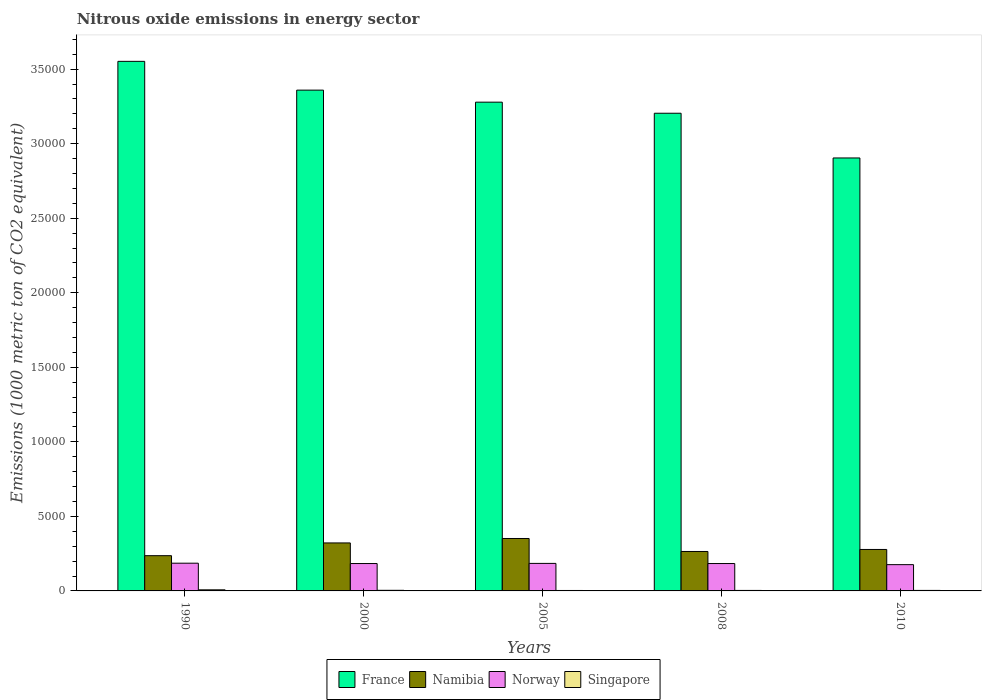How many different coloured bars are there?
Your answer should be very brief. 4. How many groups of bars are there?
Provide a succinct answer. 5. Are the number of bars on each tick of the X-axis equal?
Your response must be concise. Yes. How many bars are there on the 2nd tick from the left?
Your answer should be very brief. 4. How many bars are there on the 4th tick from the right?
Your answer should be very brief. 4. What is the label of the 3rd group of bars from the left?
Your response must be concise. 2005. What is the amount of nitrous oxide emitted in France in 2000?
Give a very brief answer. 3.36e+04. Across all years, what is the maximum amount of nitrous oxide emitted in Singapore?
Give a very brief answer. 73.5. Across all years, what is the minimum amount of nitrous oxide emitted in Norway?
Offer a terse response. 1762.1. In which year was the amount of nitrous oxide emitted in France maximum?
Provide a succinct answer. 1990. In which year was the amount of nitrous oxide emitted in Singapore minimum?
Ensure brevity in your answer.  2005. What is the total amount of nitrous oxide emitted in Namibia in the graph?
Keep it short and to the point. 1.45e+04. What is the difference between the amount of nitrous oxide emitted in France in 2000 and that in 2010?
Ensure brevity in your answer.  4549.2. What is the difference between the amount of nitrous oxide emitted in Namibia in 2000 and the amount of nitrous oxide emitted in France in 2010?
Provide a succinct answer. -2.58e+04. What is the average amount of nitrous oxide emitted in Norway per year?
Your answer should be compact. 1828.16. In the year 1990, what is the difference between the amount of nitrous oxide emitted in France and amount of nitrous oxide emitted in Singapore?
Your response must be concise. 3.54e+04. In how many years, is the amount of nitrous oxide emitted in Singapore greater than 20000 1000 metric ton?
Keep it short and to the point. 0. What is the ratio of the amount of nitrous oxide emitted in Singapore in 2008 to that in 2010?
Offer a terse response. 0.96. Is the difference between the amount of nitrous oxide emitted in France in 2000 and 2010 greater than the difference between the amount of nitrous oxide emitted in Singapore in 2000 and 2010?
Make the answer very short. Yes. What is the difference between the highest and the second highest amount of nitrous oxide emitted in France?
Your answer should be compact. 1930.3. What is the difference between the highest and the lowest amount of nitrous oxide emitted in France?
Your answer should be compact. 6479.5. In how many years, is the amount of nitrous oxide emitted in Singapore greater than the average amount of nitrous oxide emitted in Singapore taken over all years?
Your answer should be very brief. 1. Is the sum of the amount of nitrous oxide emitted in Namibia in 2008 and 2010 greater than the maximum amount of nitrous oxide emitted in France across all years?
Your answer should be very brief. No. Is it the case that in every year, the sum of the amount of nitrous oxide emitted in Singapore and amount of nitrous oxide emitted in Norway is greater than the sum of amount of nitrous oxide emitted in Namibia and amount of nitrous oxide emitted in France?
Ensure brevity in your answer.  Yes. What does the 2nd bar from the left in 1990 represents?
Offer a very short reply. Namibia. What does the 3rd bar from the right in 2008 represents?
Ensure brevity in your answer.  Namibia. Is it the case that in every year, the sum of the amount of nitrous oxide emitted in France and amount of nitrous oxide emitted in Singapore is greater than the amount of nitrous oxide emitted in Namibia?
Your response must be concise. Yes. Are all the bars in the graph horizontal?
Make the answer very short. No. What is the difference between two consecutive major ticks on the Y-axis?
Give a very brief answer. 5000. Are the values on the major ticks of Y-axis written in scientific E-notation?
Offer a terse response. No. Does the graph contain grids?
Make the answer very short. No. How are the legend labels stacked?
Keep it short and to the point. Horizontal. What is the title of the graph?
Your answer should be compact. Nitrous oxide emissions in energy sector. What is the label or title of the Y-axis?
Keep it short and to the point. Emissions (1000 metric ton of CO2 equivalent). What is the Emissions (1000 metric ton of CO2 equivalent) of France in 1990?
Give a very brief answer. 3.55e+04. What is the Emissions (1000 metric ton of CO2 equivalent) in Namibia in 1990?
Offer a very short reply. 2363.8. What is the Emissions (1000 metric ton of CO2 equivalent) of Norway in 1990?
Keep it short and to the point. 1859.7. What is the Emissions (1000 metric ton of CO2 equivalent) in Singapore in 1990?
Make the answer very short. 73.5. What is the Emissions (1000 metric ton of CO2 equivalent) of France in 2000?
Provide a succinct answer. 3.36e+04. What is the Emissions (1000 metric ton of CO2 equivalent) of Namibia in 2000?
Keep it short and to the point. 3218.7. What is the Emissions (1000 metric ton of CO2 equivalent) of Norway in 2000?
Your answer should be compact. 1836.5. What is the Emissions (1000 metric ton of CO2 equivalent) in Singapore in 2000?
Give a very brief answer. 40.5. What is the Emissions (1000 metric ton of CO2 equivalent) in France in 2005?
Your response must be concise. 3.28e+04. What is the Emissions (1000 metric ton of CO2 equivalent) in Namibia in 2005?
Keep it short and to the point. 3516.8. What is the Emissions (1000 metric ton of CO2 equivalent) of Norway in 2005?
Make the answer very short. 1846.2. What is the Emissions (1000 metric ton of CO2 equivalent) of Singapore in 2005?
Offer a terse response. 29.5. What is the Emissions (1000 metric ton of CO2 equivalent) in France in 2008?
Keep it short and to the point. 3.20e+04. What is the Emissions (1000 metric ton of CO2 equivalent) of Namibia in 2008?
Your answer should be very brief. 2645.5. What is the Emissions (1000 metric ton of CO2 equivalent) of Norway in 2008?
Provide a short and direct response. 1836.3. What is the Emissions (1000 metric ton of CO2 equivalent) in Singapore in 2008?
Offer a very short reply. 32.6. What is the Emissions (1000 metric ton of CO2 equivalent) of France in 2010?
Your answer should be compact. 2.90e+04. What is the Emissions (1000 metric ton of CO2 equivalent) of Namibia in 2010?
Your response must be concise. 2780.9. What is the Emissions (1000 metric ton of CO2 equivalent) of Norway in 2010?
Make the answer very short. 1762.1. What is the Emissions (1000 metric ton of CO2 equivalent) of Singapore in 2010?
Your answer should be compact. 34.1. Across all years, what is the maximum Emissions (1000 metric ton of CO2 equivalent) in France?
Provide a short and direct response. 3.55e+04. Across all years, what is the maximum Emissions (1000 metric ton of CO2 equivalent) of Namibia?
Keep it short and to the point. 3516.8. Across all years, what is the maximum Emissions (1000 metric ton of CO2 equivalent) in Norway?
Your answer should be compact. 1859.7. Across all years, what is the maximum Emissions (1000 metric ton of CO2 equivalent) in Singapore?
Provide a succinct answer. 73.5. Across all years, what is the minimum Emissions (1000 metric ton of CO2 equivalent) of France?
Provide a short and direct response. 2.90e+04. Across all years, what is the minimum Emissions (1000 metric ton of CO2 equivalent) of Namibia?
Give a very brief answer. 2363.8. Across all years, what is the minimum Emissions (1000 metric ton of CO2 equivalent) of Norway?
Your answer should be very brief. 1762.1. Across all years, what is the minimum Emissions (1000 metric ton of CO2 equivalent) of Singapore?
Your response must be concise. 29.5. What is the total Emissions (1000 metric ton of CO2 equivalent) of France in the graph?
Offer a terse response. 1.63e+05. What is the total Emissions (1000 metric ton of CO2 equivalent) of Namibia in the graph?
Provide a succinct answer. 1.45e+04. What is the total Emissions (1000 metric ton of CO2 equivalent) in Norway in the graph?
Provide a short and direct response. 9140.8. What is the total Emissions (1000 metric ton of CO2 equivalent) of Singapore in the graph?
Ensure brevity in your answer.  210.2. What is the difference between the Emissions (1000 metric ton of CO2 equivalent) of France in 1990 and that in 2000?
Make the answer very short. 1930.3. What is the difference between the Emissions (1000 metric ton of CO2 equivalent) of Namibia in 1990 and that in 2000?
Give a very brief answer. -854.9. What is the difference between the Emissions (1000 metric ton of CO2 equivalent) in Norway in 1990 and that in 2000?
Ensure brevity in your answer.  23.2. What is the difference between the Emissions (1000 metric ton of CO2 equivalent) of Singapore in 1990 and that in 2000?
Ensure brevity in your answer.  33. What is the difference between the Emissions (1000 metric ton of CO2 equivalent) in France in 1990 and that in 2005?
Offer a terse response. 2736.8. What is the difference between the Emissions (1000 metric ton of CO2 equivalent) in Namibia in 1990 and that in 2005?
Your answer should be very brief. -1153. What is the difference between the Emissions (1000 metric ton of CO2 equivalent) of Singapore in 1990 and that in 2005?
Offer a terse response. 44. What is the difference between the Emissions (1000 metric ton of CO2 equivalent) of France in 1990 and that in 2008?
Provide a short and direct response. 3480.3. What is the difference between the Emissions (1000 metric ton of CO2 equivalent) in Namibia in 1990 and that in 2008?
Your answer should be compact. -281.7. What is the difference between the Emissions (1000 metric ton of CO2 equivalent) in Norway in 1990 and that in 2008?
Ensure brevity in your answer.  23.4. What is the difference between the Emissions (1000 metric ton of CO2 equivalent) of Singapore in 1990 and that in 2008?
Your response must be concise. 40.9. What is the difference between the Emissions (1000 metric ton of CO2 equivalent) of France in 1990 and that in 2010?
Keep it short and to the point. 6479.5. What is the difference between the Emissions (1000 metric ton of CO2 equivalent) of Namibia in 1990 and that in 2010?
Offer a terse response. -417.1. What is the difference between the Emissions (1000 metric ton of CO2 equivalent) of Norway in 1990 and that in 2010?
Your response must be concise. 97.6. What is the difference between the Emissions (1000 metric ton of CO2 equivalent) in Singapore in 1990 and that in 2010?
Keep it short and to the point. 39.4. What is the difference between the Emissions (1000 metric ton of CO2 equivalent) of France in 2000 and that in 2005?
Offer a terse response. 806.5. What is the difference between the Emissions (1000 metric ton of CO2 equivalent) in Namibia in 2000 and that in 2005?
Your answer should be compact. -298.1. What is the difference between the Emissions (1000 metric ton of CO2 equivalent) in Norway in 2000 and that in 2005?
Your answer should be compact. -9.7. What is the difference between the Emissions (1000 metric ton of CO2 equivalent) of France in 2000 and that in 2008?
Provide a succinct answer. 1550. What is the difference between the Emissions (1000 metric ton of CO2 equivalent) in Namibia in 2000 and that in 2008?
Provide a short and direct response. 573.2. What is the difference between the Emissions (1000 metric ton of CO2 equivalent) in Norway in 2000 and that in 2008?
Provide a succinct answer. 0.2. What is the difference between the Emissions (1000 metric ton of CO2 equivalent) of France in 2000 and that in 2010?
Offer a very short reply. 4549.2. What is the difference between the Emissions (1000 metric ton of CO2 equivalent) of Namibia in 2000 and that in 2010?
Ensure brevity in your answer.  437.8. What is the difference between the Emissions (1000 metric ton of CO2 equivalent) in Norway in 2000 and that in 2010?
Provide a succinct answer. 74.4. What is the difference between the Emissions (1000 metric ton of CO2 equivalent) of France in 2005 and that in 2008?
Keep it short and to the point. 743.5. What is the difference between the Emissions (1000 metric ton of CO2 equivalent) in Namibia in 2005 and that in 2008?
Provide a succinct answer. 871.3. What is the difference between the Emissions (1000 metric ton of CO2 equivalent) in Singapore in 2005 and that in 2008?
Offer a very short reply. -3.1. What is the difference between the Emissions (1000 metric ton of CO2 equivalent) of France in 2005 and that in 2010?
Keep it short and to the point. 3742.7. What is the difference between the Emissions (1000 metric ton of CO2 equivalent) in Namibia in 2005 and that in 2010?
Your answer should be very brief. 735.9. What is the difference between the Emissions (1000 metric ton of CO2 equivalent) in Norway in 2005 and that in 2010?
Your answer should be compact. 84.1. What is the difference between the Emissions (1000 metric ton of CO2 equivalent) of Singapore in 2005 and that in 2010?
Offer a terse response. -4.6. What is the difference between the Emissions (1000 metric ton of CO2 equivalent) of France in 2008 and that in 2010?
Your response must be concise. 2999.2. What is the difference between the Emissions (1000 metric ton of CO2 equivalent) in Namibia in 2008 and that in 2010?
Provide a succinct answer. -135.4. What is the difference between the Emissions (1000 metric ton of CO2 equivalent) of Norway in 2008 and that in 2010?
Your response must be concise. 74.2. What is the difference between the Emissions (1000 metric ton of CO2 equivalent) of France in 1990 and the Emissions (1000 metric ton of CO2 equivalent) of Namibia in 2000?
Keep it short and to the point. 3.23e+04. What is the difference between the Emissions (1000 metric ton of CO2 equivalent) in France in 1990 and the Emissions (1000 metric ton of CO2 equivalent) in Norway in 2000?
Provide a short and direct response. 3.37e+04. What is the difference between the Emissions (1000 metric ton of CO2 equivalent) in France in 1990 and the Emissions (1000 metric ton of CO2 equivalent) in Singapore in 2000?
Make the answer very short. 3.55e+04. What is the difference between the Emissions (1000 metric ton of CO2 equivalent) in Namibia in 1990 and the Emissions (1000 metric ton of CO2 equivalent) in Norway in 2000?
Ensure brevity in your answer.  527.3. What is the difference between the Emissions (1000 metric ton of CO2 equivalent) in Namibia in 1990 and the Emissions (1000 metric ton of CO2 equivalent) in Singapore in 2000?
Keep it short and to the point. 2323.3. What is the difference between the Emissions (1000 metric ton of CO2 equivalent) in Norway in 1990 and the Emissions (1000 metric ton of CO2 equivalent) in Singapore in 2000?
Your answer should be very brief. 1819.2. What is the difference between the Emissions (1000 metric ton of CO2 equivalent) of France in 1990 and the Emissions (1000 metric ton of CO2 equivalent) of Namibia in 2005?
Your answer should be very brief. 3.20e+04. What is the difference between the Emissions (1000 metric ton of CO2 equivalent) in France in 1990 and the Emissions (1000 metric ton of CO2 equivalent) in Norway in 2005?
Your answer should be very brief. 3.37e+04. What is the difference between the Emissions (1000 metric ton of CO2 equivalent) of France in 1990 and the Emissions (1000 metric ton of CO2 equivalent) of Singapore in 2005?
Your answer should be very brief. 3.55e+04. What is the difference between the Emissions (1000 metric ton of CO2 equivalent) of Namibia in 1990 and the Emissions (1000 metric ton of CO2 equivalent) of Norway in 2005?
Your answer should be compact. 517.6. What is the difference between the Emissions (1000 metric ton of CO2 equivalent) in Namibia in 1990 and the Emissions (1000 metric ton of CO2 equivalent) in Singapore in 2005?
Your answer should be compact. 2334.3. What is the difference between the Emissions (1000 metric ton of CO2 equivalent) of Norway in 1990 and the Emissions (1000 metric ton of CO2 equivalent) of Singapore in 2005?
Ensure brevity in your answer.  1830.2. What is the difference between the Emissions (1000 metric ton of CO2 equivalent) of France in 1990 and the Emissions (1000 metric ton of CO2 equivalent) of Namibia in 2008?
Provide a succinct answer. 3.29e+04. What is the difference between the Emissions (1000 metric ton of CO2 equivalent) of France in 1990 and the Emissions (1000 metric ton of CO2 equivalent) of Norway in 2008?
Provide a succinct answer. 3.37e+04. What is the difference between the Emissions (1000 metric ton of CO2 equivalent) in France in 1990 and the Emissions (1000 metric ton of CO2 equivalent) in Singapore in 2008?
Give a very brief answer. 3.55e+04. What is the difference between the Emissions (1000 metric ton of CO2 equivalent) in Namibia in 1990 and the Emissions (1000 metric ton of CO2 equivalent) in Norway in 2008?
Make the answer very short. 527.5. What is the difference between the Emissions (1000 metric ton of CO2 equivalent) of Namibia in 1990 and the Emissions (1000 metric ton of CO2 equivalent) of Singapore in 2008?
Ensure brevity in your answer.  2331.2. What is the difference between the Emissions (1000 metric ton of CO2 equivalent) in Norway in 1990 and the Emissions (1000 metric ton of CO2 equivalent) in Singapore in 2008?
Make the answer very short. 1827.1. What is the difference between the Emissions (1000 metric ton of CO2 equivalent) in France in 1990 and the Emissions (1000 metric ton of CO2 equivalent) in Namibia in 2010?
Your answer should be very brief. 3.27e+04. What is the difference between the Emissions (1000 metric ton of CO2 equivalent) of France in 1990 and the Emissions (1000 metric ton of CO2 equivalent) of Norway in 2010?
Make the answer very short. 3.38e+04. What is the difference between the Emissions (1000 metric ton of CO2 equivalent) in France in 1990 and the Emissions (1000 metric ton of CO2 equivalent) in Singapore in 2010?
Your answer should be compact. 3.55e+04. What is the difference between the Emissions (1000 metric ton of CO2 equivalent) of Namibia in 1990 and the Emissions (1000 metric ton of CO2 equivalent) of Norway in 2010?
Give a very brief answer. 601.7. What is the difference between the Emissions (1000 metric ton of CO2 equivalent) in Namibia in 1990 and the Emissions (1000 metric ton of CO2 equivalent) in Singapore in 2010?
Offer a very short reply. 2329.7. What is the difference between the Emissions (1000 metric ton of CO2 equivalent) in Norway in 1990 and the Emissions (1000 metric ton of CO2 equivalent) in Singapore in 2010?
Provide a short and direct response. 1825.6. What is the difference between the Emissions (1000 metric ton of CO2 equivalent) of France in 2000 and the Emissions (1000 metric ton of CO2 equivalent) of Namibia in 2005?
Offer a terse response. 3.01e+04. What is the difference between the Emissions (1000 metric ton of CO2 equivalent) in France in 2000 and the Emissions (1000 metric ton of CO2 equivalent) in Norway in 2005?
Your answer should be compact. 3.17e+04. What is the difference between the Emissions (1000 metric ton of CO2 equivalent) of France in 2000 and the Emissions (1000 metric ton of CO2 equivalent) of Singapore in 2005?
Your answer should be very brief. 3.36e+04. What is the difference between the Emissions (1000 metric ton of CO2 equivalent) of Namibia in 2000 and the Emissions (1000 metric ton of CO2 equivalent) of Norway in 2005?
Make the answer very short. 1372.5. What is the difference between the Emissions (1000 metric ton of CO2 equivalent) of Namibia in 2000 and the Emissions (1000 metric ton of CO2 equivalent) of Singapore in 2005?
Your answer should be very brief. 3189.2. What is the difference between the Emissions (1000 metric ton of CO2 equivalent) in Norway in 2000 and the Emissions (1000 metric ton of CO2 equivalent) in Singapore in 2005?
Provide a short and direct response. 1807. What is the difference between the Emissions (1000 metric ton of CO2 equivalent) in France in 2000 and the Emissions (1000 metric ton of CO2 equivalent) in Namibia in 2008?
Give a very brief answer. 3.09e+04. What is the difference between the Emissions (1000 metric ton of CO2 equivalent) of France in 2000 and the Emissions (1000 metric ton of CO2 equivalent) of Norway in 2008?
Your response must be concise. 3.18e+04. What is the difference between the Emissions (1000 metric ton of CO2 equivalent) in France in 2000 and the Emissions (1000 metric ton of CO2 equivalent) in Singapore in 2008?
Your response must be concise. 3.36e+04. What is the difference between the Emissions (1000 metric ton of CO2 equivalent) in Namibia in 2000 and the Emissions (1000 metric ton of CO2 equivalent) in Norway in 2008?
Your answer should be very brief. 1382.4. What is the difference between the Emissions (1000 metric ton of CO2 equivalent) in Namibia in 2000 and the Emissions (1000 metric ton of CO2 equivalent) in Singapore in 2008?
Give a very brief answer. 3186.1. What is the difference between the Emissions (1000 metric ton of CO2 equivalent) in Norway in 2000 and the Emissions (1000 metric ton of CO2 equivalent) in Singapore in 2008?
Keep it short and to the point. 1803.9. What is the difference between the Emissions (1000 metric ton of CO2 equivalent) of France in 2000 and the Emissions (1000 metric ton of CO2 equivalent) of Namibia in 2010?
Offer a terse response. 3.08e+04. What is the difference between the Emissions (1000 metric ton of CO2 equivalent) of France in 2000 and the Emissions (1000 metric ton of CO2 equivalent) of Norway in 2010?
Offer a terse response. 3.18e+04. What is the difference between the Emissions (1000 metric ton of CO2 equivalent) of France in 2000 and the Emissions (1000 metric ton of CO2 equivalent) of Singapore in 2010?
Ensure brevity in your answer.  3.36e+04. What is the difference between the Emissions (1000 metric ton of CO2 equivalent) of Namibia in 2000 and the Emissions (1000 metric ton of CO2 equivalent) of Norway in 2010?
Your response must be concise. 1456.6. What is the difference between the Emissions (1000 metric ton of CO2 equivalent) in Namibia in 2000 and the Emissions (1000 metric ton of CO2 equivalent) in Singapore in 2010?
Offer a terse response. 3184.6. What is the difference between the Emissions (1000 metric ton of CO2 equivalent) in Norway in 2000 and the Emissions (1000 metric ton of CO2 equivalent) in Singapore in 2010?
Offer a terse response. 1802.4. What is the difference between the Emissions (1000 metric ton of CO2 equivalent) of France in 2005 and the Emissions (1000 metric ton of CO2 equivalent) of Namibia in 2008?
Your answer should be very brief. 3.01e+04. What is the difference between the Emissions (1000 metric ton of CO2 equivalent) of France in 2005 and the Emissions (1000 metric ton of CO2 equivalent) of Norway in 2008?
Provide a short and direct response. 3.09e+04. What is the difference between the Emissions (1000 metric ton of CO2 equivalent) in France in 2005 and the Emissions (1000 metric ton of CO2 equivalent) in Singapore in 2008?
Make the answer very short. 3.28e+04. What is the difference between the Emissions (1000 metric ton of CO2 equivalent) in Namibia in 2005 and the Emissions (1000 metric ton of CO2 equivalent) in Norway in 2008?
Your answer should be compact. 1680.5. What is the difference between the Emissions (1000 metric ton of CO2 equivalent) in Namibia in 2005 and the Emissions (1000 metric ton of CO2 equivalent) in Singapore in 2008?
Provide a succinct answer. 3484.2. What is the difference between the Emissions (1000 metric ton of CO2 equivalent) in Norway in 2005 and the Emissions (1000 metric ton of CO2 equivalent) in Singapore in 2008?
Your answer should be very brief. 1813.6. What is the difference between the Emissions (1000 metric ton of CO2 equivalent) of France in 2005 and the Emissions (1000 metric ton of CO2 equivalent) of Namibia in 2010?
Offer a very short reply. 3.00e+04. What is the difference between the Emissions (1000 metric ton of CO2 equivalent) in France in 2005 and the Emissions (1000 metric ton of CO2 equivalent) in Norway in 2010?
Your answer should be compact. 3.10e+04. What is the difference between the Emissions (1000 metric ton of CO2 equivalent) in France in 2005 and the Emissions (1000 metric ton of CO2 equivalent) in Singapore in 2010?
Provide a short and direct response. 3.27e+04. What is the difference between the Emissions (1000 metric ton of CO2 equivalent) of Namibia in 2005 and the Emissions (1000 metric ton of CO2 equivalent) of Norway in 2010?
Your answer should be compact. 1754.7. What is the difference between the Emissions (1000 metric ton of CO2 equivalent) in Namibia in 2005 and the Emissions (1000 metric ton of CO2 equivalent) in Singapore in 2010?
Keep it short and to the point. 3482.7. What is the difference between the Emissions (1000 metric ton of CO2 equivalent) in Norway in 2005 and the Emissions (1000 metric ton of CO2 equivalent) in Singapore in 2010?
Make the answer very short. 1812.1. What is the difference between the Emissions (1000 metric ton of CO2 equivalent) of France in 2008 and the Emissions (1000 metric ton of CO2 equivalent) of Namibia in 2010?
Keep it short and to the point. 2.93e+04. What is the difference between the Emissions (1000 metric ton of CO2 equivalent) of France in 2008 and the Emissions (1000 metric ton of CO2 equivalent) of Norway in 2010?
Provide a succinct answer. 3.03e+04. What is the difference between the Emissions (1000 metric ton of CO2 equivalent) in France in 2008 and the Emissions (1000 metric ton of CO2 equivalent) in Singapore in 2010?
Your answer should be compact. 3.20e+04. What is the difference between the Emissions (1000 metric ton of CO2 equivalent) in Namibia in 2008 and the Emissions (1000 metric ton of CO2 equivalent) in Norway in 2010?
Keep it short and to the point. 883.4. What is the difference between the Emissions (1000 metric ton of CO2 equivalent) of Namibia in 2008 and the Emissions (1000 metric ton of CO2 equivalent) of Singapore in 2010?
Give a very brief answer. 2611.4. What is the difference between the Emissions (1000 metric ton of CO2 equivalent) in Norway in 2008 and the Emissions (1000 metric ton of CO2 equivalent) in Singapore in 2010?
Offer a terse response. 1802.2. What is the average Emissions (1000 metric ton of CO2 equivalent) in France per year?
Provide a short and direct response. 3.26e+04. What is the average Emissions (1000 metric ton of CO2 equivalent) in Namibia per year?
Offer a very short reply. 2905.14. What is the average Emissions (1000 metric ton of CO2 equivalent) of Norway per year?
Give a very brief answer. 1828.16. What is the average Emissions (1000 metric ton of CO2 equivalent) in Singapore per year?
Your answer should be compact. 42.04. In the year 1990, what is the difference between the Emissions (1000 metric ton of CO2 equivalent) of France and Emissions (1000 metric ton of CO2 equivalent) of Namibia?
Offer a terse response. 3.32e+04. In the year 1990, what is the difference between the Emissions (1000 metric ton of CO2 equivalent) in France and Emissions (1000 metric ton of CO2 equivalent) in Norway?
Offer a terse response. 3.37e+04. In the year 1990, what is the difference between the Emissions (1000 metric ton of CO2 equivalent) of France and Emissions (1000 metric ton of CO2 equivalent) of Singapore?
Offer a terse response. 3.54e+04. In the year 1990, what is the difference between the Emissions (1000 metric ton of CO2 equivalent) in Namibia and Emissions (1000 metric ton of CO2 equivalent) in Norway?
Provide a succinct answer. 504.1. In the year 1990, what is the difference between the Emissions (1000 metric ton of CO2 equivalent) in Namibia and Emissions (1000 metric ton of CO2 equivalent) in Singapore?
Give a very brief answer. 2290.3. In the year 1990, what is the difference between the Emissions (1000 metric ton of CO2 equivalent) in Norway and Emissions (1000 metric ton of CO2 equivalent) in Singapore?
Your response must be concise. 1786.2. In the year 2000, what is the difference between the Emissions (1000 metric ton of CO2 equivalent) of France and Emissions (1000 metric ton of CO2 equivalent) of Namibia?
Offer a very short reply. 3.04e+04. In the year 2000, what is the difference between the Emissions (1000 metric ton of CO2 equivalent) in France and Emissions (1000 metric ton of CO2 equivalent) in Norway?
Offer a terse response. 3.18e+04. In the year 2000, what is the difference between the Emissions (1000 metric ton of CO2 equivalent) of France and Emissions (1000 metric ton of CO2 equivalent) of Singapore?
Make the answer very short. 3.35e+04. In the year 2000, what is the difference between the Emissions (1000 metric ton of CO2 equivalent) of Namibia and Emissions (1000 metric ton of CO2 equivalent) of Norway?
Offer a terse response. 1382.2. In the year 2000, what is the difference between the Emissions (1000 metric ton of CO2 equivalent) in Namibia and Emissions (1000 metric ton of CO2 equivalent) in Singapore?
Provide a succinct answer. 3178.2. In the year 2000, what is the difference between the Emissions (1000 metric ton of CO2 equivalent) in Norway and Emissions (1000 metric ton of CO2 equivalent) in Singapore?
Give a very brief answer. 1796. In the year 2005, what is the difference between the Emissions (1000 metric ton of CO2 equivalent) in France and Emissions (1000 metric ton of CO2 equivalent) in Namibia?
Make the answer very short. 2.93e+04. In the year 2005, what is the difference between the Emissions (1000 metric ton of CO2 equivalent) in France and Emissions (1000 metric ton of CO2 equivalent) in Norway?
Keep it short and to the point. 3.09e+04. In the year 2005, what is the difference between the Emissions (1000 metric ton of CO2 equivalent) in France and Emissions (1000 metric ton of CO2 equivalent) in Singapore?
Offer a terse response. 3.28e+04. In the year 2005, what is the difference between the Emissions (1000 metric ton of CO2 equivalent) in Namibia and Emissions (1000 metric ton of CO2 equivalent) in Norway?
Keep it short and to the point. 1670.6. In the year 2005, what is the difference between the Emissions (1000 metric ton of CO2 equivalent) in Namibia and Emissions (1000 metric ton of CO2 equivalent) in Singapore?
Provide a short and direct response. 3487.3. In the year 2005, what is the difference between the Emissions (1000 metric ton of CO2 equivalent) of Norway and Emissions (1000 metric ton of CO2 equivalent) of Singapore?
Keep it short and to the point. 1816.7. In the year 2008, what is the difference between the Emissions (1000 metric ton of CO2 equivalent) of France and Emissions (1000 metric ton of CO2 equivalent) of Namibia?
Your answer should be very brief. 2.94e+04. In the year 2008, what is the difference between the Emissions (1000 metric ton of CO2 equivalent) of France and Emissions (1000 metric ton of CO2 equivalent) of Norway?
Your response must be concise. 3.02e+04. In the year 2008, what is the difference between the Emissions (1000 metric ton of CO2 equivalent) in France and Emissions (1000 metric ton of CO2 equivalent) in Singapore?
Ensure brevity in your answer.  3.20e+04. In the year 2008, what is the difference between the Emissions (1000 metric ton of CO2 equivalent) of Namibia and Emissions (1000 metric ton of CO2 equivalent) of Norway?
Offer a terse response. 809.2. In the year 2008, what is the difference between the Emissions (1000 metric ton of CO2 equivalent) in Namibia and Emissions (1000 metric ton of CO2 equivalent) in Singapore?
Offer a terse response. 2612.9. In the year 2008, what is the difference between the Emissions (1000 metric ton of CO2 equivalent) in Norway and Emissions (1000 metric ton of CO2 equivalent) in Singapore?
Your answer should be very brief. 1803.7. In the year 2010, what is the difference between the Emissions (1000 metric ton of CO2 equivalent) of France and Emissions (1000 metric ton of CO2 equivalent) of Namibia?
Your response must be concise. 2.63e+04. In the year 2010, what is the difference between the Emissions (1000 metric ton of CO2 equivalent) of France and Emissions (1000 metric ton of CO2 equivalent) of Norway?
Provide a short and direct response. 2.73e+04. In the year 2010, what is the difference between the Emissions (1000 metric ton of CO2 equivalent) of France and Emissions (1000 metric ton of CO2 equivalent) of Singapore?
Your answer should be compact. 2.90e+04. In the year 2010, what is the difference between the Emissions (1000 metric ton of CO2 equivalent) of Namibia and Emissions (1000 metric ton of CO2 equivalent) of Norway?
Your response must be concise. 1018.8. In the year 2010, what is the difference between the Emissions (1000 metric ton of CO2 equivalent) of Namibia and Emissions (1000 metric ton of CO2 equivalent) of Singapore?
Your answer should be very brief. 2746.8. In the year 2010, what is the difference between the Emissions (1000 metric ton of CO2 equivalent) in Norway and Emissions (1000 metric ton of CO2 equivalent) in Singapore?
Make the answer very short. 1728. What is the ratio of the Emissions (1000 metric ton of CO2 equivalent) in France in 1990 to that in 2000?
Give a very brief answer. 1.06. What is the ratio of the Emissions (1000 metric ton of CO2 equivalent) of Namibia in 1990 to that in 2000?
Provide a short and direct response. 0.73. What is the ratio of the Emissions (1000 metric ton of CO2 equivalent) of Norway in 1990 to that in 2000?
Your response must be concise. 1.01. What is the ratio of the Emissions (1000 metric ton of CO2 equivalent) of Singapore in 1990 to that in 2000?
Provide a short and direct response. 1.81. What is the ratio of the Emissions (1000 metric ton of CO2 equivalent) in France in 1990 to that in 2005?
Your response must be concise. 1.08. What is the ratio of the Emissions (1000 metric ton of CO2 equivalent) in Namibia in 1990 to that in 2005?
Give a very brief answer. 0.67. What is the ratio of the Emissions (1000 metric ton of CO2 equivalent) of Norway in 1990 to that in 2005?
Offer a terse response. 1.01. What is the ratio of the Emissions (1000 metric ton of CO2 equivalent) of Singapore in 1990 to that in 2005?
Keep it short and to the point. 2.49. What is the ratio of the Emissions (1000 metric ton of CO2 equivalent) in France in 1990 to that in 2008?
Your response must be concise. 1.11. What is the ratio of the Emissions (1000 metric ton of CO2 equivalent) of Namibia in 1990 to that in 2008?
Offer a very short reply. 0.89. What is the ratio of the Emissions (1000 metric ton of CO2 equivalent) in Norway in 1990 to that in 2008?
Offer a very short reply. 1.01. What is the ratio of the Emissions (1000 metric ton of CO2 equivalent) of Singapore in 1990 to that in 2008?
Give a very brief answer. 2.25. What is the ratio of the Emissions (1000 metric ton of CO2 equivalent) of France in 1990 to that in 2010?
Your answer should be very brief. 1.22. What is the ratio of the Emissions (1000 metric ton of CO2 equivalent) in Namibia in 1990 to that in 2010?
Your answer should be very brief. 0.85. What is the ratio of the Emissions (1000 metric ton of CO2 equivalent) in Norway in 1990 to that in 2010?
Ensure brevity in your answer.  1.06. What is the ratio of the Emissions (1000 metric ton of CO2 equivalent) of Singapore in 1990 to that in 2010?
Your answer should be very brief. 2.16. What is the ratio of the Emissions (1000 metric ton of CO2 equivalent) of France in 2000 to that in 2005?
Ensure brevity in your answer.  1.02. What is the ratio of the Emissions (1000 metric ton of CO2 equivalent) in Namibia in 2000 to that in 2005?
Your answer should be very brief. 0.92. What is the ratio of the Emissions (1000 metric ton of CO2 equivalent) in Norway in 2000 to that in 2005?
Make the answer very short. 0.99. What is the ratio of the Emissions (1000 metric ton of CO2 equivalent) in Singapore in 2000 to that in 2005?
Give a very brief answer. 1.37. What is the ratio of the Emissions (1000 metric ton of CO2 equivalent) of France in 2000 to that in 2008?
Your answer should be compact. 1.05. What is the ratio of the Emissions (1000 metric ton of CO2 equivalent) of Namibia in 2000 to that in 2008?
Offer a very short reply. 1.22. What is the ratio of the Emissions (1000 metric ton of CO2 equivalent) in Singapore in 2000 to that in 2008?
Keep it short and to the point. 1.24. What is the ratio of the Emissions (1000 metric ton of CO2 equivalent) of France in 2000 to that in 2010?
Ensure brevity in your answer.  1.16. What is the ratio of the Emissions (1000 metric ton of CO2 equivalent) of Namibia in 2000 to that in 2010?
Provide a succinct answer. 1.16. What is the ratio of the Emissions (1000 metric ton of CO2 equivalent) in Norway in 2000 to that in 2010?
Provide a short and direct response. 1.04. What is the ratio of the Emissions (1000 metric ton of CO2 equivalent) of Singapore in 2000 to that in 2010?
Keep it short and to the point. 1.19. What is the ratio of the Emissions (1000 metric ton of CO2 equivalent) of France in 2005 to that in 2008?
Provide a succinct answer. 1.02. What is the ratio of the Emissions (1000 metric ton of CO2 equivalent) of Namibia in 2005 to that in 2008?
Provide a short and direct response. 1.33. What is the ratio of the Emissions (1000 metric ton of CO2 equivalent) in Norway in 2005 to that in 2008?
Offer a terse response. 1.01. What is the ratio of the Emissions (1000 metric ton of CO2 equivalent) of Singapore in 2005 to that in 2008?
Your answer should be compact. 0.9. What is the ratio of the Emissions (1000 metric ton of CO2 equivalent) of France in 2005 to that in 2010?
Give a very brief answer. 1.13. What is the ratio of the Emissions (1000 metric ton of CO2 equivalent) of Namibia in 2005 to that in 2010?
Ensure brevity in your answer.  1.26. What is the ratio of the Emissions (1000 metric ton of CO2 equivalent) of Norway in 2005 to that in 2010?
Your answer should be very brief. 1.05. What is the ratio of the Emissions (1000 metric ton of CO2 equivalent) of Singapore in 2005 to that in 2010?
Your answer should be compact. 0.87. What is the ratio of the Emissions (1000 metric ton of CO2 equivalent) of France in 2008 to that in 2010?
Give a very brief answer. 1.1. What is the ratio of the Emissions (1000 metric ton of CO2 equivalent) of Namibia in 2008 to that in 2010?
Make the answer very short. 0.95. What is the ratio of the Emissions (1000 metric ton of CO2 equivalent) in Norway in 2008 to that in 2010?
Ensure brevity in your answer.  1.04. What is the ratio of the Emissions (1000 metric ton of CO2 equivalent) in Singapore in 2008 to that in 2010?
Provide a succinct answer. 0.96. What is the difference between the highest and the second highest Emissions (1000 metric ton of CO2 equivalent) in France?
Ensure brevity in your answer.  1930.3. What is the difference between the highest and the second highest Emissions (1000 metric ton of CO2 equivalent) of Namibia?
Your answer should be compact. 298.1. What is the difference between the highest and the second highest Emissions (1000 metric ton of CO2 equivalent) of Norway?
Offer a very short reply. 13.5. What is the difference between the highest and the second highest Emissions (1000 metric ton of CO2 equivalent) of Singapore?
Make the answer very short. 33. What is the difference between the highest and the lowest Emissions (1000 metric ton of CO2 equivalent) of France?
Offer a terse response. 6479.5. What is the difference between the highest and the lowest Emissions (1000 metric ton of CO2 equivalent) in Namibia?
Give a very brief answer. 1153. What is the difference between the highest and the lowest Emissions (1000 metric ton of CO2 equivalent) in Norway?
Give a very brief answer. 97.6. What is the difference between the highest and the lowest Emissions (1000 metric ton of CO2 equivalent) of Singapore?
Your answer should be very brief. 44. 